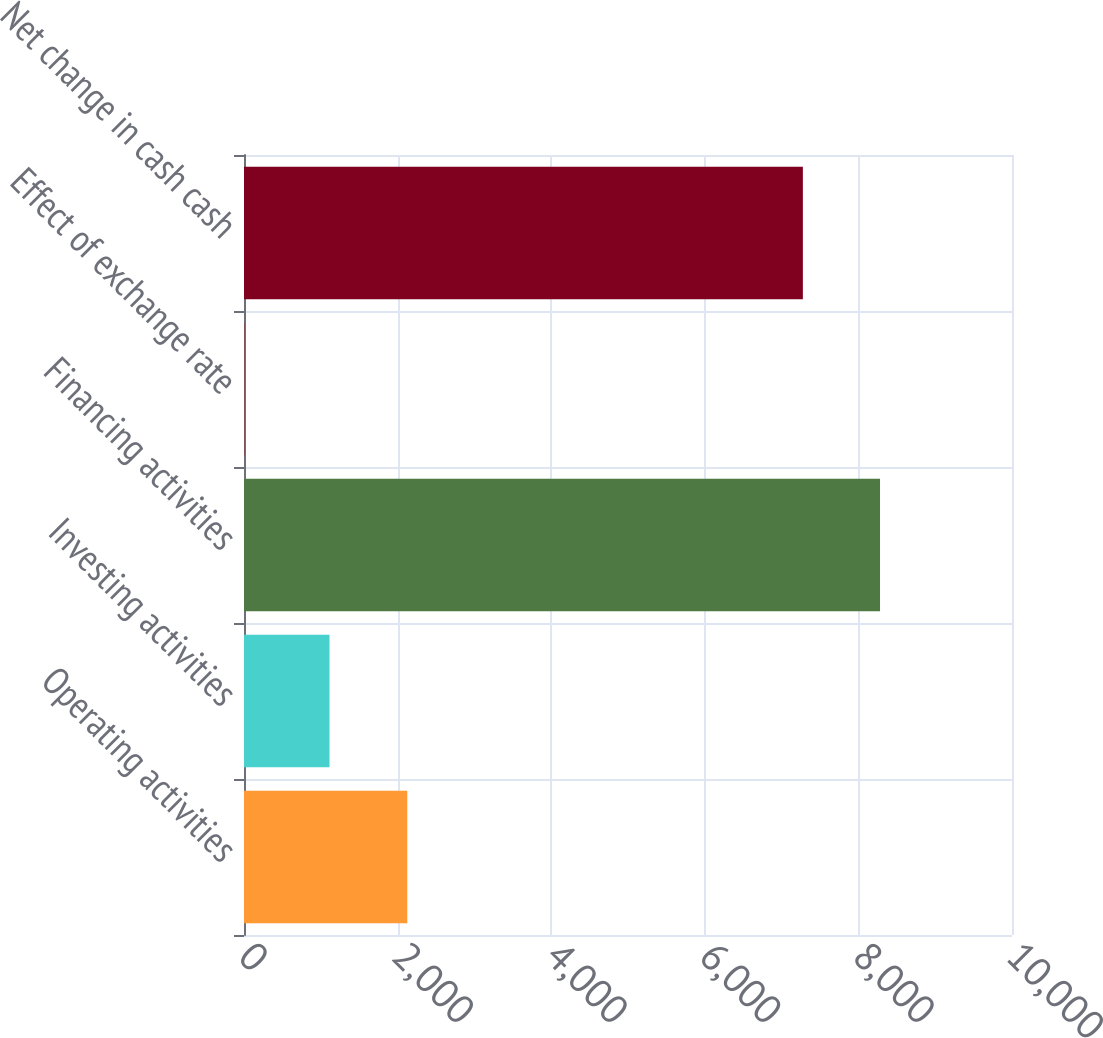Convert chart. <chart><loc_0><loc_0><loc_500><loc_500><bar_chart><fcel>Operating activities<fcel>Investing activities<fcel>Financing activities<fcel>Effect of exchange rate<fcel>Net change in cash cash<nl><fcel>2125.9<fcel>1113.2<fcel>8281.7<fcel>8<fcel>7277<nl></chart> 